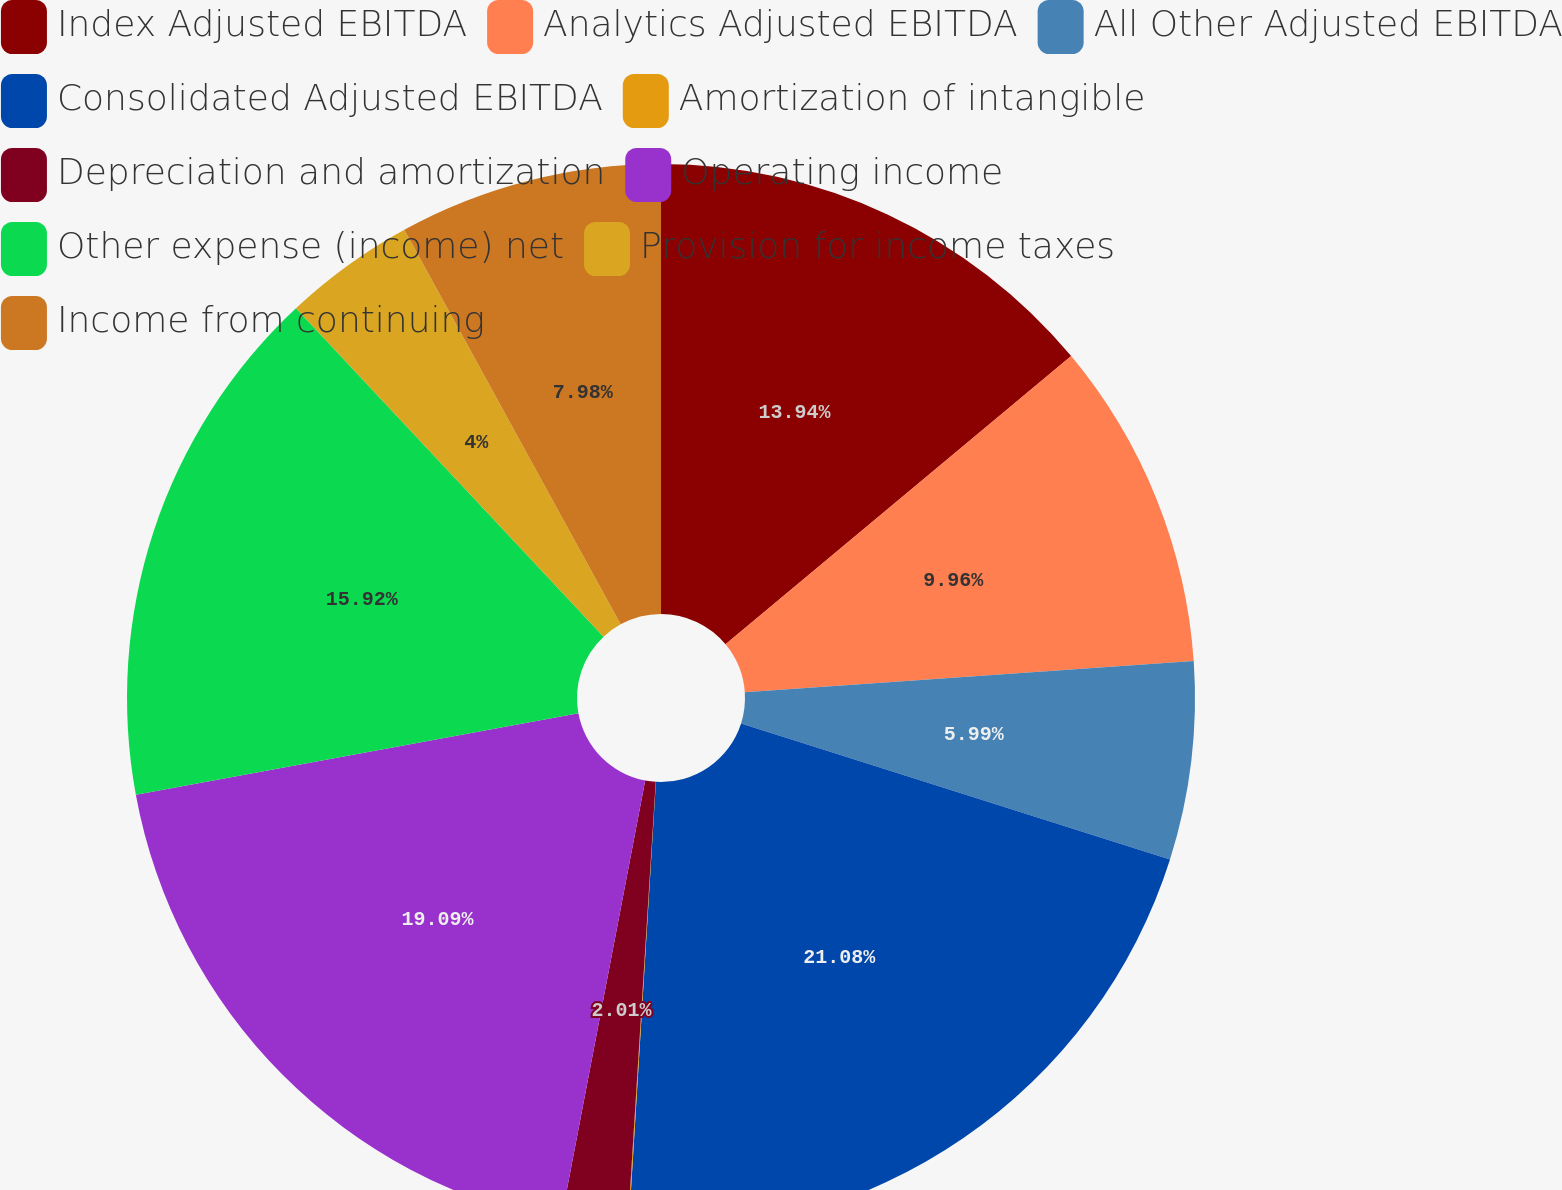Convert chart. <chart><loc_0><loc_0><loc_500><loc_500><pie_chart><fcel>Index Adjusted EBITDA<fcel>Analytics Adjusted EBITDA<fcel>All Other Adjusted EBITDA<fcel>Consolidated Adjusted EBITDA<fcel>Amortization of intangible<fcel>Depreciation and amortization<fcel>Operating income<fcel>Other expense (income) net<fcel>Provision for income taxes<fcel>Income from continuing<nl><fcel>13.94%<fcel>9.96%<fcel>5.99%<fcel>21.08%<fcel>0.03%<fcel>2.01%<fcel>19.09%<fcel>15.92%<fcel>4.0%<fcel>7.98%<nl></chart> 